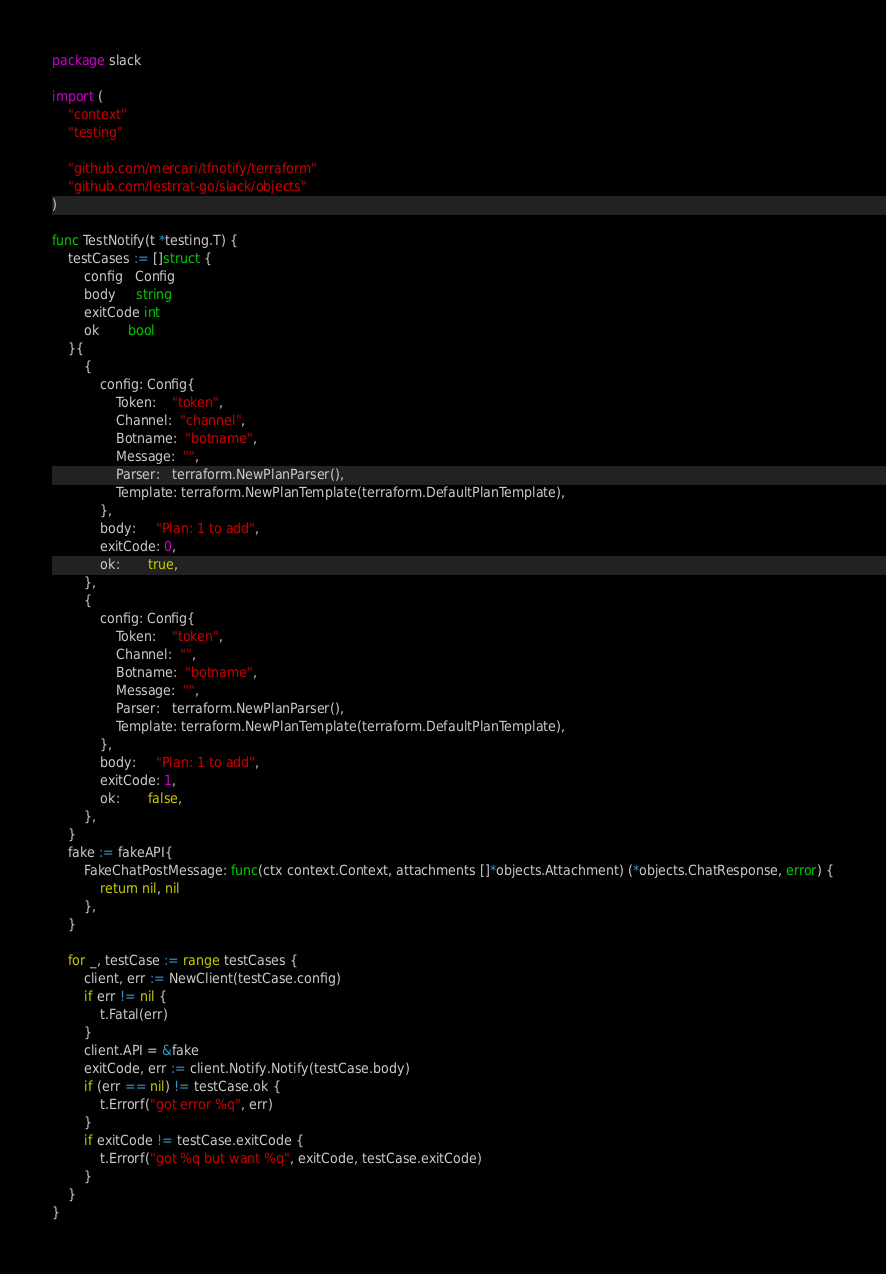<code> <loc_0><loc_0><loc_500><loc_500><_Go_>package slack

import (
	"context"
	"testing"

	"github.com/mercari/tfnotify/terraform"
	"github.com/lestrrat-go/slack/objects"
)

func TestNotify(t *testing.T) {
	testCases := []struct {
		config   Config
		body     string
		exitCode int
		ok       bool
	}{
		{
			config: Config{
				Token:    "token",
				Channel:  "channel",
				Botname:  "botname",
				Message:  "",
				Parser:   terraform.NewPlanParser(),
				Template: terraform.NewPlanTemplate(terraform.DefaultPlanTemplate),
			},
			body:     "Plan: 1 to add",
			exitCode: 0,
			ok:       true,
		},
		{
			config: Config{
				Token:    "token",
				Channel:  "",
				Botname:  "botname",
				Message:  "",
				Parser:   terraform.NewPlanParser(),
				Template: terraform.NewPlanTemplate(terraform.DefaultPlanTemplate),
			},
			body:     "Plan: 1 to add",
			exitCode: 1,
			ok:       false,
		},
	}
	fake := fakeAPI{
		FakeChatPostMessage: func(ctx context.Context, attachments []*objects.Attachment) (*objects.ChatResponse, error) {
			return nil, nil
		},
	}

	for _, testCase := range testCases {
		client, err := NewClient(testCase.config)
		if err != nil {
			t.Fatal(err)
		}
		client.API = &fake
		exitCode, err := client.Notify.Notify(testCase.body)
		if (err == nil) != testCase.ok {
			t.Errorf("got error %q", err)
		}
		if exitCode != testCase.exitCode {
			t.Errorf("got %q but want %q", exitCode, testCase.exitCode)
		}
	}
}
</code> 